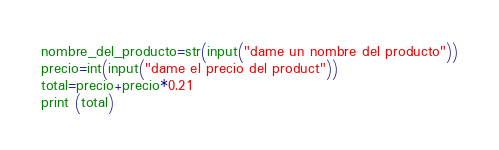Convert code to text. <code><loc_0><loc_0><loc_500><loc_500><_Python_>nombre_del_producto=str(input("dame un nombre del producto"))
precio=int(input("dame el precio del product"))
total=precio+precio*0.21
print (total)
</code> 